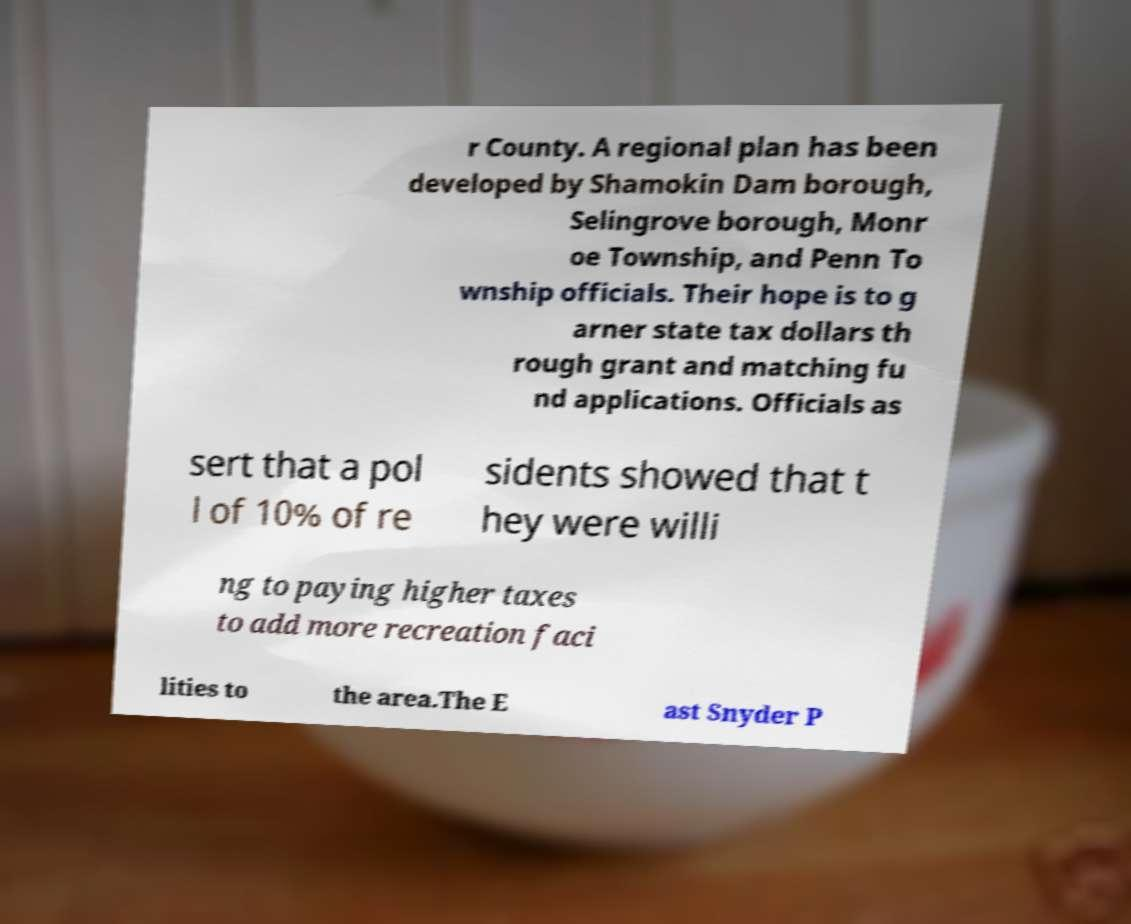Please identify and transcribe the text found in this image. r County. A regional plan has been developed by Shamokin Dam borough, Selingrove borough, Monr oe Township, and Penn To wnship officials. Their hope is to g arner state tax dollars th rough grant and matching fu nd applications. Officials as sert that a pol l of 10% of re sidents showed that t hey were willi ng to paying higher taxes to add more recreation faci lities to the area.The E ast Snyder P 